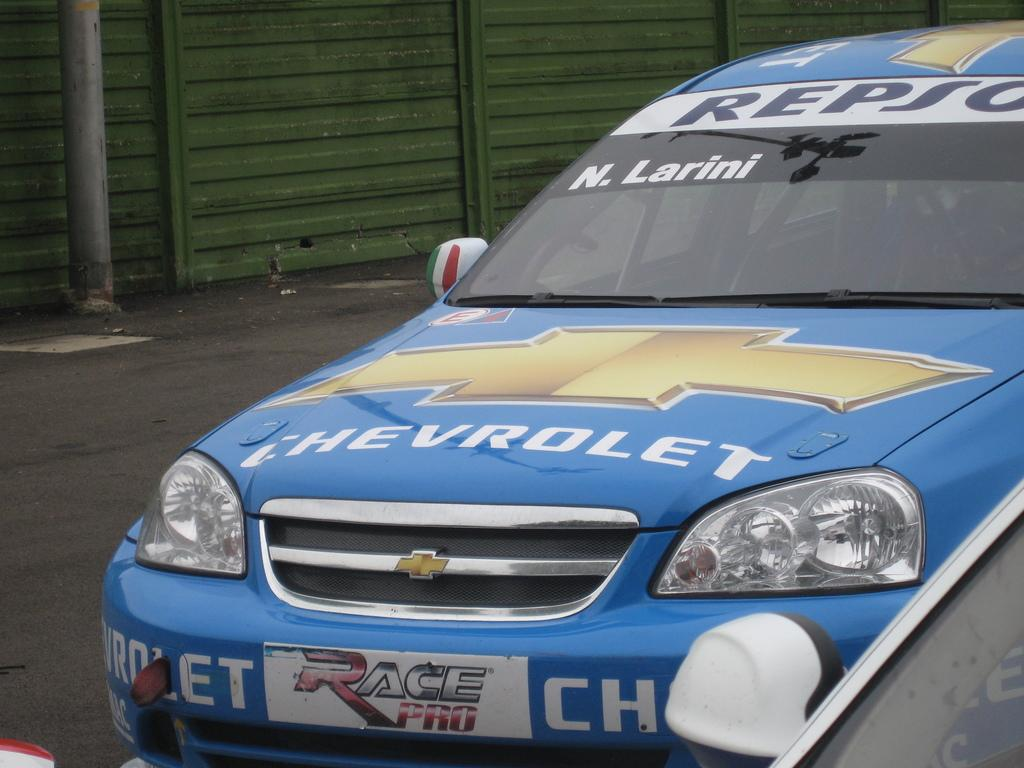What is the main subject in the center of the image? There is a sports car in the center of the image. What can be seen in the background of the image? There is a pole, a road, and a fence in the background of the image. Reasoning: Let' Let's think step by step in order to produce the conversation. We start by identifying the main subject in the image, which is the sports car. Then, we expand the conversation to include other elements that are visible in the background, such as the pole, road, and fence. Each question is designed to elicit a specific detail about the image that is known from the provided facts. Absurd Question/Answer: What type of stone is visible on the mountain in the image? There is no mountain present in the image, so it is not possible to determine what type of stone might be visible. What type of pan is being used to cook on the mountain in the image? There is no mountain or pan present in the image, so it is not possible to determine what type of pan might be used for cooking. 